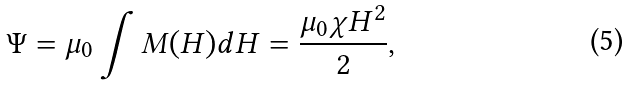Convert formula to latex. <formula><loc_0><loc_0><loc_500><loc_500>\Psi = \mu _ { 0 } \int M ( H ) d H = \frac { \mu _ { 0 } \chi H ^ { 2 } } { 2 } ,</formula> 